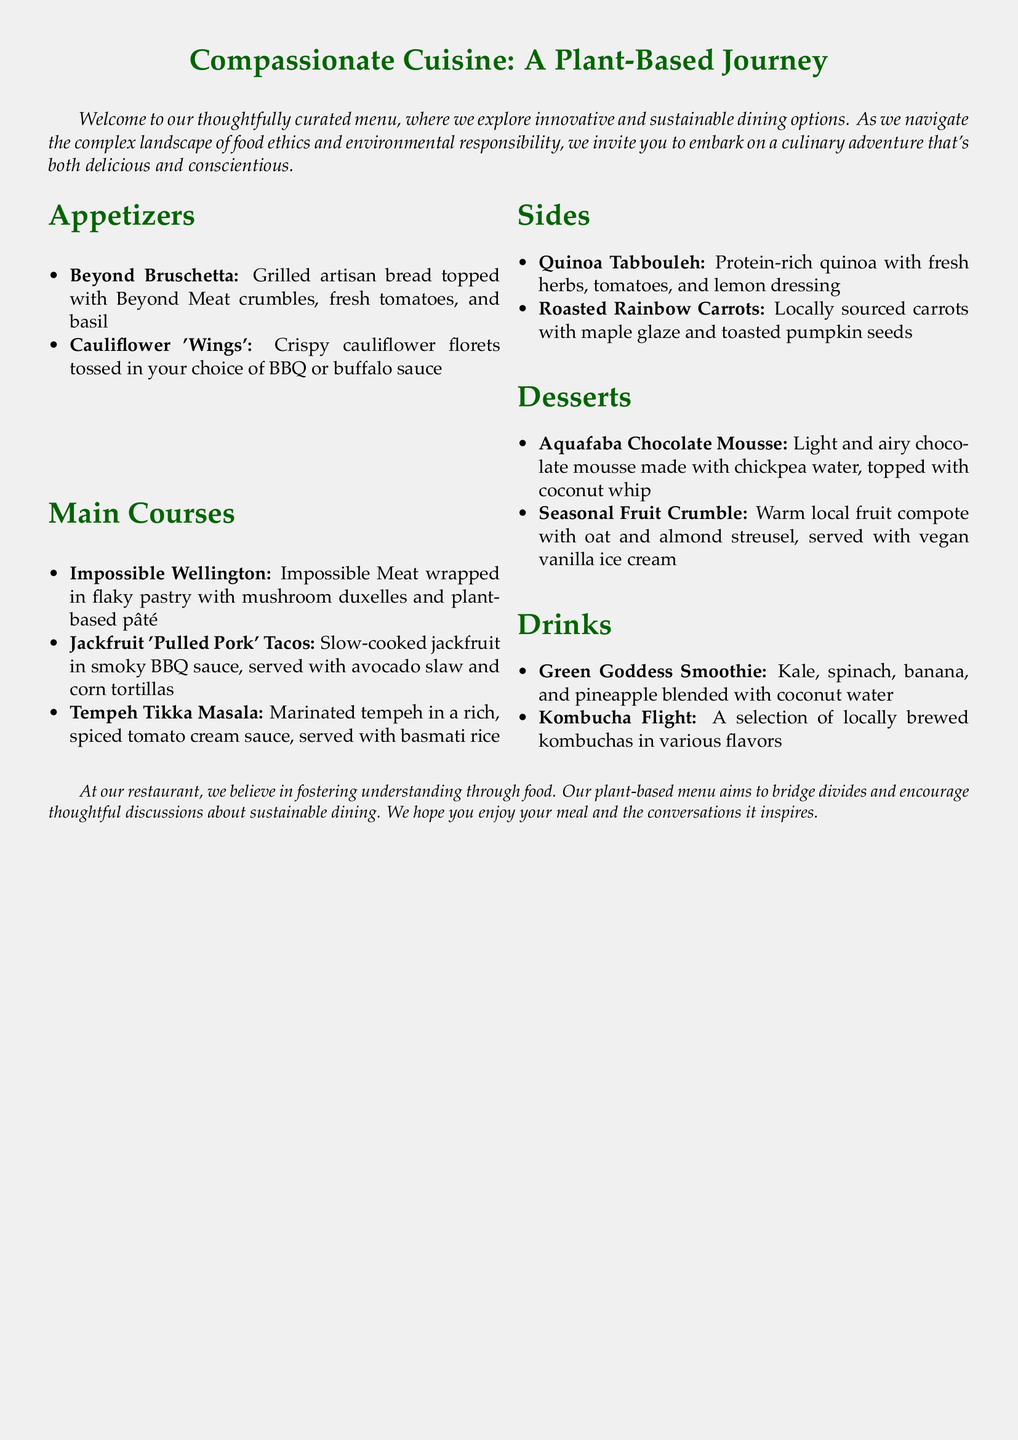What is the name of the first appetizer? The first appetizer listed is "Beyond Bruschetta" in the appetizers section.
Answer: Beyond Bruschetta How many main courses are featured on the menu? There are three items listed under the main courses section: Impossible Wellington, Jackfruit 'Pulled Pork' Tacos, and Tempeh Tikka Masala.
Answer: Three What is the key ingredient in the Aquafaba Chocolate Mousse? The mousse is made with chickpea water, commonly known as aquafaba, serving as a unique plant-based ingredient.
Answer: Chickpea water Which side dish includes locally sourced carrots? The side dish that includes locally sourced carrots is "Roasted Rainbow Carrots," as specified in the sides section.
Answer: Roasted Rainbow Carrots What type of drink can you sample in a flight? The drink you can sample in a flight is a selection of locally brewed kombuchas, as mentioned in the drinks section.
Answer: Kombucha What is the main component of the Quinoa Tabbouleh? The main component is quinoa, featured in the sides section as a protein-rich dish.
Answer: Quinoa What dessert features a warm local fruit compote? The dessert is "Seasonal Fruit Crumble," which includes the warm local fruit compote as part of its description.
Answer: Seasonal Fruit Crumble What is the primary vegetable in the Green Goddess Smoothie? The primary vegetable in the smoothie is kale, as listed in the ingredients of that drink.
Answer: Kale Which dish is described as having a rich, spiced tomato cream sauce? The dish is "Tempeh Tikka Masala," identified in the main courses section.
Answer: Tempeh Tikka Masala 